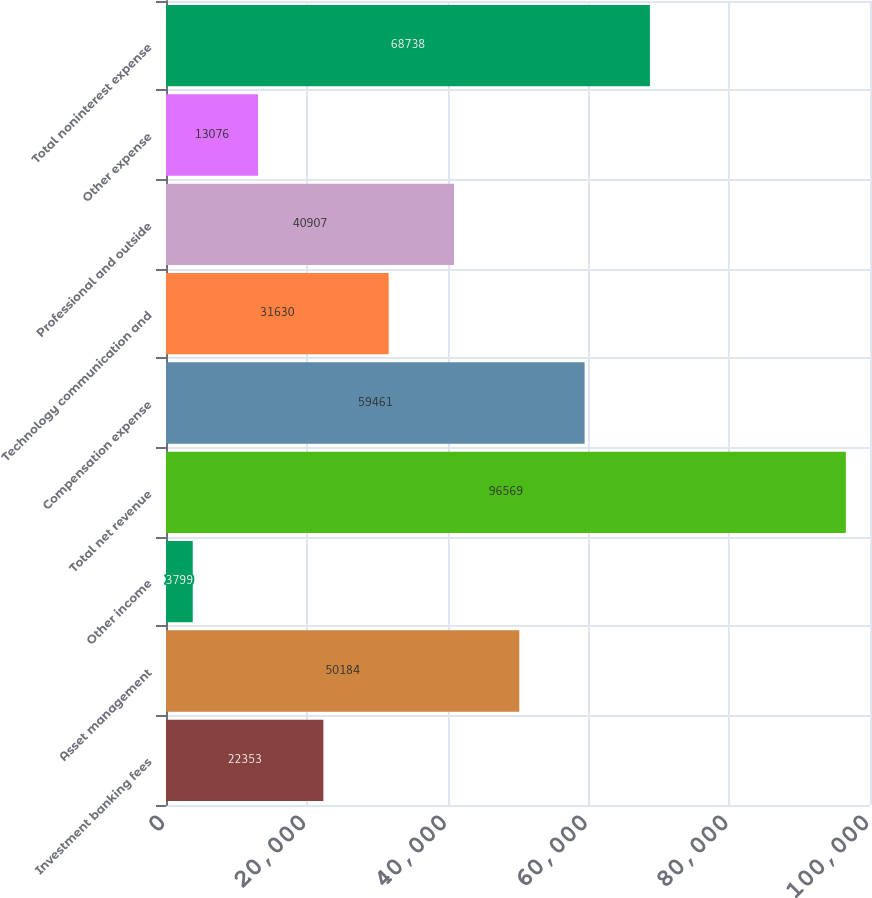Convert chart to OTSL. <chart><loc_0><loc_0><loc_500><loc_500><bar_chart><fcel>Investment banking fees<fcel>Asset management<fcel>Other income<fcel>Total net revenue<fcel>Compensation expense<fcel>Technology communication and<fcel>Professional and outside<fcel>Other expense<fcel>Total noninterest expense<nl><fcel>22353<fcel>50184<fcel>3799<fcel>96569<fcel>59461<fcel>31630<fcel>40907<fcel>13076<fcel>68738<nl></chart> 